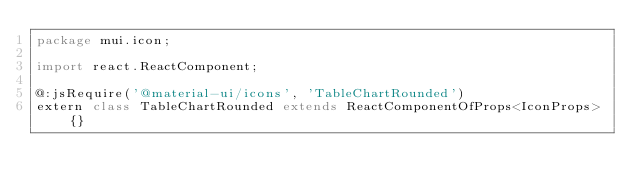Convert code to text. <code><loc_0><loc_0><loc_500><loc_500><_Haxe_>package mui.icon;

import react.ReactComponent;

@:jsRequire('@material-ui/icons', 'TableChartRounded')
extern class TableChartRounded extends ReactComponentOfProps<IconProps> {}
</code> 